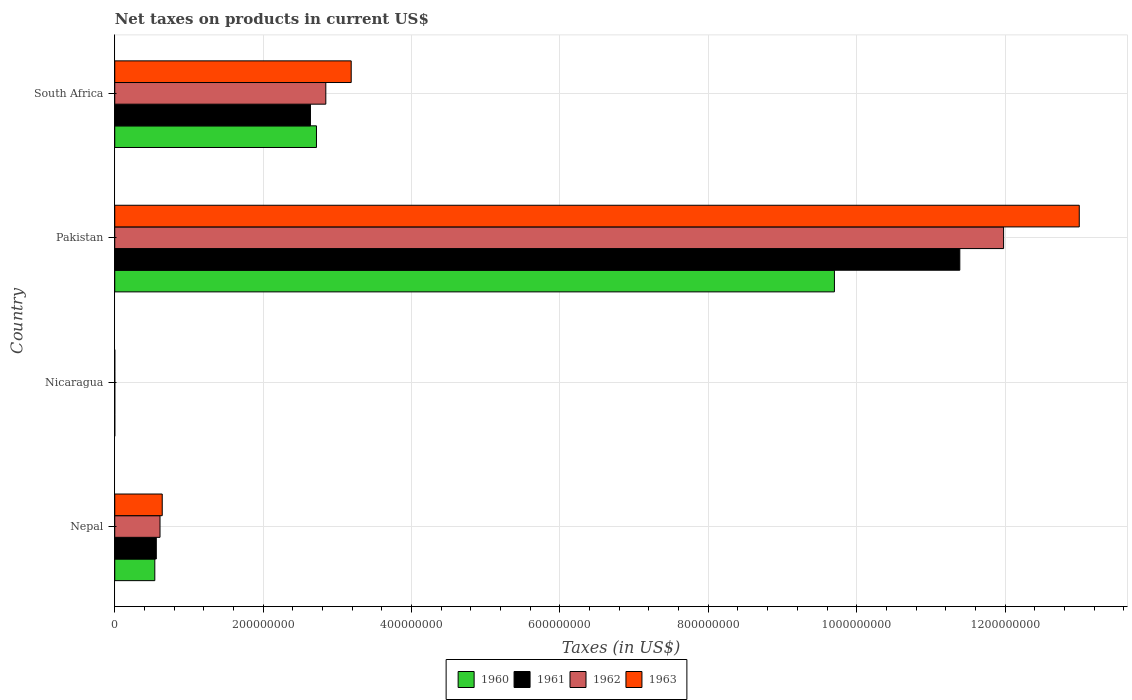Are the number of bars on each tick of the Y-axis equal?
Make the answer very short. Yes. How many bars are there on the 2nd tick from the bottom?
Your response must be concise. 4. What is the label of the 3rd group of bars from the top?
Make the answer very short. Nicaragua. In how many cases, is the number of bars for a given country not equal to the number of legend labels?
Ensure brevity in your answer.  0. What is the net taxes on products in 1962 in Nicaragua?
Your answer should be very brief. 0.04. Across all countries, what is the maximum net taxes on products in 1963?
Ensure brevity in your answer.  1.30e+09. Across all countries, what is the minimum net taxes on products in 1960?
Ensure brevity in your answer.  0.03. In which country was the net taxes on products in 1960 minimum?
Your answer should be compact. Nicaragua. What is the total net taxes on products in 1962 in the graph?
Keep it short and to the point. 1.54e+09. What is the difference between the net taxes on products in 1963 in Nicaragua and that in Pakistan?
Ensure brevity in your answer.  -1.30e+09. What is the difference between the net taxes on products in 1962 in Nepal and the net taxes on products in 1961 in Pakistan?
Provide a short and direct response. -1.08e+09. What is the average net taxes on products in 1962 per country?
Provide a short and direct response. 3.86e+08. What is the difference between the net taxes on products in 1963 and net taxes on products in 1961 in Nicaragua?
Your answer should be compact. 0.01. What is the ratio of the net taxes on products in 1963 in Pakistan to that in South Africa?
Your answer should be very brief. 4.08. Is the net taxes on products in 1962 in Nepal less than that in Nicaragua?
Provide a succinct answer. No. What is the difference between the highest and the second highest net taxes on products in 1960?
Give a very brief answer. 6.98e+08. What is the difference between the highest and the lowest net taxes on products in 1962?
Your answer should be compact. 1.20e+09. In how many countries, is the net taxes on products in 1963 greater than the average net taxes on products in 1963 taken over all countries?
Offer a very short reply. 1. Is the sum of the net taxes on products in 1961 in Nicaragua and Pakistan greater than the maximum net taxes on products in 1960 across all countries?
Keep it short and to the point. Yes. What does the 1st bar from the top in Nepal represents?
Provide a short and direct response. 1963. What does the 2nd bar from the bottom in Pakistan represents?
Ensure brevity in your answer.  1961. Is it the case that in every country, the sum of the net taxes on products in 1960 and net taxes on products in 1961 is greater than the net taxes on products in 1963?
Your answer should be compact. Yes. Are all the bars in the graph horizontal?
Your answer should be very brief. Yes. What is the difference between two consecutive major ticks on the X-axis?
Offer a very short reply. 2.00e+08. Does the graph contain any zero values?
Provide a succinct answer. No. Where does the legend appear in the graph?
Keep it short and to the point. Bottom center. What is the title of the graph?
Your response must be concise. Net taxes on products in current US$. Does "1980" appear as one of the legend labels in the graph?
Your answer should be very brief. No. What is the label or title of the X-axis?
Ensure brevity in your answer.  Taxes (in US$). What is the label or title of the Y-axis?
Ensure brevity in your answer.  Country. What is the Taxes (in US$) of 1960 in Nepal?
Your answer should be very brief. 5.40e+07. What is the Taxes (in US$) in 1961 in Nepal?
Keep it short and to the point. 5.60e+07. What is the Taxes (in US$) of 1962 in Nepal?
Your response must be concise. 6.10e+07. What is the Taxes (in US$) in 1963 in Nepal?
Make the answer very short. 6.40e+07. What is the Taxes (in US$) in 1960 in Nicaragua?
Your answer should be compact. 0.03. What is the Taxes (in US$) of 1961 in Nicaragua?
Make the answer very short. 0.03. What is the Taxes (in US$) in 1962 in Nicaragua?
Your answer should be compact. 0.04. What is the Taxes (in US$) of 1963 in Nicaragua?
Offer a terse response. 0.04. What is the Taxes (in US$) of 1960 in Pakistan?
Make the answer very short. 9.70e+08. What is the Taxes (in US$) in 1961 in Pakistan?
Keep it short and to the point. 1.14e+09. What is the Taxes (in US$) in 1962 in Pakistan?
Give a very brief answer. 1.20e+09. What is the Taxes (in US$) of 1963 in Pakistan?
Give a very brief answer. 1.30e+09. What is the Taxes (in US$) in 1960 in South Africa?
Offer a terse response. 2.72e+08. What is the Taxes (in US$) of 1961 in South Africa?
Keep it short and to the point. 2.64e+08. What is the Taxes (in US$) of 1962 in South Africa?
Provide a succinct answer. 2.84e+08. What is the Taxes (in US$) of 1963 in South Africa?
Keep it short and to the point. 3.19e+08. Across all countries, what is the maximum Taxes (in US$) of 1960?
Make the answer very short. 9.70e+08. Across all countries, what is the maximum Taxes (in US$) of 1961?
Give a very brief answer. 1.14e+09. Across all countries, what is the maximum Taxes (in US$) in 1962?
Your response must be concise. 1.20e+09. Across all countries, what is the maximum Taxes (in US$) of 1963?
Ensure brevity in your answer.  1.30e+09. Across all countries, what is the minimum Taxes (in US$) in 1960?
Provide a succinct answer. 0.03. Across all countries, what is the minimum Taxes (in US$) in 1961?
Offer a terse response. 0.03. Across all countries, what is the minimum Taxes (in US$) of 1962?
Your answer should be compact. 0.04. Across all countries, what is the minimum Taxes (in US$) in 1963?
Your answer should be compact. 0.04. What is the total Taxes (in US$) of 1960 in the graph?
Provide a short and direct response. 1.30e+09. What is the total Taxes (in US$) in 1961 in the graph?
Your response must be concise. 1.46e+09. What is the total Taxes (in US$) of 1962 in the graph?
Ensure brevity in your answer.  1.54e+09. What is the total Taxes (in US$) of 1963 in the graph?
Give a very brief answer. 1.68e+09. What is the difference between the Taxes (in US$) of 1960 in Nepal and that in Nicaragua?
Provide a short and direct response. 5.40e+07. What is the difference between the Taxes (in US$) of 1961 in Nepal and that in Nicaragua?
Your response must be concise. 5.60e+07. What is the difference between the Taxes (in US$) of 1962 in Nepal and that in Nicaragua?
Provide a succinct answer. 6.10e+07. What is the difference between the Taxes (in US$) of 1963 in Nepal and that in Nicaragua?
Give a very brief answer. 6.40e+07. What is the difference between the Taxes (in US$) in 1960 in Nepal and that in Pakistan?
Ensure brevity in your answer.  -9.16e+08. What is the difference between the Taxes (in US$) of 1961 in Nepal and that in Pakistan?
Give a very brief answer. -1.08e+09. What is the difference between the Taxes (in US$) in 1962 in Nepal and that in Pakistan?
Your answer should be compact. -1.14e+09. What is the difference between the Taxes (in US$) in 1963 in Nepal and that in Pakistan?
Your response must be concise. -1.24e+09. What is the difference between the Taxes (in US$) of 1960 in Nepal and that in South Africa?
Provide a short and direct response. -2.18e+08. What is the difference between the Taxes (in US$) of 1961 in Nepal and that in South Africa?
Provide a short and direct response. -2.08e+08. What is the difference between the Taxes (in US$) in 1962 in Nepal and that in South Africa?
Give a very brief answer. -2.23e+08. What is the difference between the Taxes (in US$) in 1963 in Nepal and that in South Africa?
Your response must be concise. -2.55e+08. What is the difference between the Taxes (in US$) of 1960 in Nicaragua and that in Pakistan?
Your response must be concise. -9.70e+08. What is the difference between the Taxes (in US$) of 1961 in Nicaragua and that in Pakistan?
Offer a very short reply. -1.14e+09. What is the difference between the Taxes (in US$) in 1962 in Nicaragua and that in Pakistan?
Your response must be concise. -1.20e+09. What is the difference between the Taxes (in US$) in 1963 in Nicaragua and that in Pakistan?
Provide a short and direct response. -1.30e+09. What is the difference between the Taxes (in US$) of 1960 in Nicaragua and that in South Africa?
Your answer should be very brief. -2.72e+08. What is the difference between the Taxes (in US$) in 1961 in Nicaragua and that in South Africa?
Offer a terse response. -2.64e+08. What is the difference between the Taxes (in US$) in 1962 in Nicaragua and that in South Africa?
Keep it short and to the point. -2.84e+08. What is the difference between the Taxes (in US$) in 1963 in Nicaragua and that in South Africa?
Your answer should be very brief. -3.19e+08. What is the difference between the Taxes (in US$) of 1960 in Pakistan and that in South Africa?
Your answer should be very brief. 6.98e+08. What is the difference between the Taxes (in US$) of 1961 in Pakistan and that in South Africa?
Your answer should be very brief. 8.75e+08. What is the difference between the Taxes (in US$) in 1962 in Pakistan and that in South Africa?
Ensure brevity in your answer.  9.14e+08. What is the difference between the Taxes (in US$) in 1963 in Pakistan and that in South Africa?
Your response must be concise. 9.81e+08. What is the difference between the Taxes (in US$) of 1960 in Nepal and the Taxes (in US$) of 1961 in Nicaragua?
Provide a short and direct response. 5.40e+07. What is the difference between the Taxes (in US$) in 1960 in Nepal and the Taxes (in US$) in 1962 in Nicaragua?
Your answer should be compact. 5.40e+07. What is the difference between the Taxes (in US$) of 1960 in Nepal and the Taxes (in US$) of 1963 in Nicaragua?
Give a very brief answer. 5.40e+07. What is the difference between the Taxes (in US$) of 1961 in Nepal and the Taxes (in US$) of 1962 in Nicaragua?
Provide a succinct answer. 5.60e+07. What is the difference between the Taxes (in US$) in 1961 in Nepal and the Taxes (in US$) in 1963 in Nicaragua?
Provide a succinct answer. 5.60e+07. What is the difference between the Taxes (in US$) in 1962 in Nepal and the Taxes (in US$) in 1963 in Nicaragua?
Give a very brief answer. 6.10e+07. What is the difference between the Taxes (in US$) of 1960 in Nepal and the Taxes (in US$) of 1961 in Pakistan?
Your answer should be very brief. -1.08e+09. What is the difference between the Taxes (in US$) of 1960 in Nepal and the Taxes (in US$) of 1962 in Pakistan?
Keep it short and to the point. -1.14e+09. What is the difference between the Taxes (in US$) in 1960 in Nepal and the Taxes (in US$) in 1963 in Pakistan?
Ensure brevity in your answer.  -1.25e+09. What is the difference between the Taxes (in US$) in 1961 in Nepal and the Taxes (in US$) in 1962 in Pakistan?
Give a very brief answer. -1.14e+09. What is the difference between the Taxes (in US$) in 1961 in Nepal and the Taxes (in US$) in 1963 in Pakistan?
Provide a short and direct response. -1.24e+09. What is the difference between the Taxes (in US$) in 1962 in Nepal and the Taxes (in US$) in 1963 in Pakistan?
Provide a succinct answer. -1.24e+09. What is the difference between the Taxes (in US$) in 1960 in Nepal and the Taxes (in US$) in 1961 in South Africa?
Your answer should be very brief. -2.10e+08. What is the difference between the Taxes (in US$) in 1960 in Nepal and the Taxes (in US$) in 1962 in South Africa?
Offer a very short reply. -2.30e+08. What is the difference between the Taxes (in US$) of 1960 in Nepal and the Taxes (in US$) of 1963 in South Africa?
Keep it short and to the point. -2.65e+08. What is the difference between the Taxes (in US$) of 1961 in Nepal and the Taxes (in US$) of 1962 in South Africa?
Provide a succinct answer. -2.28e+08. What is the difference between the Taxes (in US$) in 1961 in Nepal and the Taxes (in US$) in 1963 in South Africa?
Your answer should be very brief. -2.63e+08. What is the difference between the Taxes (in US$) of 1962 in Nepal and the Taxes (in US$) of 1963 in South Africa?
Offer a terse response. -2.58e+08. What is the difference between the Taxes (in US$) of 1960 in Nicaragua and the Taxes (in US$) of 1961 in Pakistan?
Keep it short and to the point. -1.14e+09. What is the difference between the Taxes (in US$) of 1960 in Nicaragua and the Taxes (in US$) of 1962 in Pakistan?
Keep it short and to the point. -1.20e+09. What is the difference between the Taxes (in US$) in 1960 in Nicaragua and the Taxes (in US$) in 1963 in Pakistan?
Give a very brief answer. -1.30e+09. What is the difference between the Taxes (in US$) of 1961 in Nicaragua and the Taxes (in US$) of 1962 in Pakistan?
Your answer should be compact. -1.20e+09. What is the difference between the Taxes (in US$) in 1961 in Nicaragua and the Taxes (in US$) in 1963 in Pakistan?
Your answer should be very brief. -1.30e+09. What is the difference between the Taxes (in US$) in 1962 in Nicaragua and the Taxes (in US$) in 1963 in Pakistan?
Make the answer very short. -1.30e+09. What is the difference between the Taxes (in US$) of 1960 in Nicaragua and the Taxes (in US$) of 1961 in South Africa?
Your answer should be very brief. -2.64e+08. What is the difference between the Taxes (in US$) in 1960 in Nicaragua and the Taxes (in US$) in 1962 in South Africa?
Your answer should be very brief. -2.84e+08. What is the difference between the Taxes (in US$) in 1960 in Nicaragua and the Taxes (in US$) in 1963 in South Africa?
Provide a short and direct response. -3.19e+08. What is the difference between the Taxes (in US$) in 1961 in Nicaragua and the Taxes (in US$) in 1962 in South Africa?
Ensure brevity in your answer.  -2.84e+08. What is the difference between the Taxes (in US$) in 1961 in Nicaragua and the Taxes (in US$) in 1963 in South Africa?
Offer a very short reply. -3.19e+08. What is the difference between the Taxes (in US$) of 1962 in Nicaragua and the Taxes (in US$) of 1963 in South Africa?
Your answer should be compact. -3.19e+08. What is the difference between the Taxes (in US$) of 1960 in Pakistan and the Taxes (in US$) of 1961 in South Africa?
Make the answer very short. 7.06e+08. What is the difference between the Taxes (in US$) of 1960 in Pakistan and the Taxes (in US$) of 1962 in South Africa?
Make the answer very short. 6.86e+08. What is the difference between the Taxes (in US$) of 1960 in Pakistan and the Taxes (in US$) of 1963 in South Africa?
Offer a very short reply. 6.51e+08. What is the difference between the Taxes (in US$) in 1961 in Pakistan and the Taxes (in US$) in 1962 in South Africa?
Provide a succinct answer. 8.55e+08. What is the difference between the Taxes (in US$) of 1961 in Pakistan and the Taxes (in US$) of 1963 in South Africa?
Your answer should be compact. 8.20e+08. What is the difference between the Taxes (in US$) in 1962 in Pakistan and the Taxes (in US$) in 1963 in South Africa?
Make the answer very short. 8.79e+08. What is the average Taxes (in US$) in 1960 per country?
Your answer should be compact. 3.24e+08. What is the average Taxes (in US$) of 1961 per country?
Your response must be concise. 3.65e+08. What is the average Taxes (in US$) in 1962 per country?
Make the answer very short. 3.86e+08. What is the average Taxes (in US$) in 1963 per country?
Your answer should be compact. 4.21e+08. What is the difference between the Taxes (in US$) of 1960 and Taxes (in US$) of 1961 in Nepal?
Keep it short and to the point. -2.00e+06. What is the difference between the Taxes (in US$) of 1960 and Taxes (in US$) of 1962 in Nepal?
Give a very brief answer. -7.00e+06. What is the difference between the Taxes (in US$) in 1960 and Taxes (in US$) in 1963 in Nepal?
Your response must be concise. -1.00e+07. What is the difference between the Taxes (in US$) of 1961 and Taxes (in US$) of 1962 in Nepal?
Offer a terse response. -5.00e+06. What is the difference between the Taxes (in US$) of 1961 and Taxes (in US$) of 1963 in Nepal?
Provide a short and direct response. -8.00e+06. What is the difference between the Taxes (in US$) in 1962 and Taxes (in US$) in 1963 in Nepal?
Your answer should be very brief. -3.00e+06. What is the difference between the Taxes (in US$) of 1960 and Taxes (in US$) of 1961 in Nicaragua?
Provide a short and direct response. -0. What is the difference between the Taxes (in US$) of 1960 and Taxes (in US$) of 1962 in Nicaragua?
Keep it short and to the point. -0.01. What is the difference between the Taxes (in US$) of 1960 and Taxes (in US$) of 1963 in Nicaragua?
Your answer should be compact. -0.01. What is the difference between the Taxes (in US$) in 1961 and Taxes (in US$) in 1962 in Nicaragua?
Make the answer very short. -0. What is the difference between the Taxes (in US$) of 1961 and Taxes (in US$) of 1963 in Nicaragua?
Offer a terse response. -0.01. What is the difference between the Taxes (in US$) in 1962 and Taxes (in US$) in 1963 in Nicaragua?
Make the answer very short. -0.01. What is the difference between the Taxes (in US$) in 1960 and Taxes (in US$) in 1961 in Pakistan?
Offer a terse response. -1.69e+08. What is the difference between the Taxes (in US$) in 1960 and Taxes (in US$) in 1962 in Pakistan?
Your response must be concise. -2.28e+08. What is the difference between the Taxes (in US$) of 1960 and Taxes (in US$) of 1963 in Pakistan?
Your answer should be very brief. -3.30e+08. What is the difference between the Taxes (in US$) in 1961 and Taxes (in US$) in 1962 in Pakistan?
Offer a terse response. -5.90e+07. What is the difference between the Taxes (in US$) in 1961 and Taxes (in US$) in 1963 in Pakistan?
Give a very brief answer. -1.61e+08. What is the difference between the Taxes (in US$) of 1962 and Taxes (in US$) of 1963 in Pakistan?
Give a very brief answer. -1.02e+08. What is the difference between the Taxes (in US$) of 1960 and Taxes (in US$) of 1961 in South Africa?
Your answer should be compact. 8.10e+06. What is the difference between the Taxes (in US$) of 1960 and Taxes (in US$) of 1962 in South Africa?
Offer a terse response. -1.26e+07. What is the difference between the Taxes (in US$) of 1960 and Taxes (in US$) of 1963 in South Africa?
Provide a succinct answer. -4.68e+07. What is the difference between the Taxes (in US$) of 1961 and Taxes (in US$) of 1962 in South Africa?
Provide a short and direct response. -2.07e+07. What is the difference between the Taxes (in US$) in 1961 and Taxes (in US$) in 1963 in South Africa?
Ensure brevity in your answer.  -5.49e+07. What is the difference between the Taxes (in US$) in 1962 and Taxes (in US$) in 1963 in South Africa?
Your answer should be very brief. -3.42e+07. What is the ratio of the Taxes (in US$) of 1960 in Nepal to that in Nicaragua?
Offer a terse response. 1.81e+09. What is the ratio of the Taxes (in US$) of 1961 in Nepal to that in Nicaragua?
Keep it short and to the point. 1.80e+09. What is the ratio of the Taxes (in US$) of 1962 in Nepal to that in Nicaragua?
Offer a very short reply. 1.73e+09. What is the ratio of the Taxes (in US$) of 1963 in Nepal to that in Nicaragua?
Offer a very short reply. 1.54e+09. What is the ratio of the Taxes (in US$) in 1960 in Nepal to that in Pakistan?
Provide a succinct answer. 0.06. What is the ratio of the Taxes (in US$) of 1961 in Nepal to that in Pakistan?
Provide a short and direct response. 0.05. What is the ratio of the Taxes (in US$) of 1962 in Nepal to that in Pakistan?
Your answer should be compact. 0.05. What is the ratio of the Taxes (in US$) in 1963 in Nepal to that in Pakistan?
Provide a short and direct response. 0.05. What is the ratio of the Taxes (in US$) in 1960 in Nepal to that in South Africa?
Provide a succinct answer. 0.2. What is the ratio of the Taxes (in US$) of 1961 in Nepal to that in South Africa?
Your response must be concise. 0.21. What is the ratio of the Taxes (in US$) in 1962 in Nepal to that in South Africa?
Your response must be concise. 0.21. What is the ratio of the Taxes (in US$) in 1963 in Nepal to that in South Africa?
Provide a short and direct response. 0.2. What is the ratio of the Taxes (in US$) of 1961 in Nicaragua to that in Pakistan?
Your answer should be very brief. 0. What is the ratio of the Taxes (in US$) of 1960 in Nicaragua to that in South Africa?
Provide a short and direct response. 0. What is the ratio of the Taxes (in US$) of 1963 in Nicaragua to that in South Africa?
Your answer should be compact. 0. What is the ratio of the Taxes (in US$) in 1960 in Pakistan to that in South Africa?
Offer a terse response. 3.57. What is the ratio of the Taxes (in US$) of 1961 in Pakistan to that in South Africa?
Offer a terse response. 4.32. What is the ratio of the Taxes (in US$) of 1962 in Pakistan to that in South Africa?
Provide a short and direct response. 4.21. What is the ratio of the Taxes (in US$) in 1963 in Pakistan to that in South Africa?
Ensure brevity in your answer.  4.08. What is the difference between the highest and the second highest Taxes (in US$) of 1960?
Give a very brief answer. 6.98e+08. What is the difference between the highest and the second highest Taxes (in US$) of 1961?
Give a very brief answer. 8.75e+08. What is the difference between the highest and the second highest Taxes (in US$) of 1962?
Provide a succinct answer. 9.14e+08. What is the difference between the highest and the second highest Taxes (in US$) of 1963?
Provide a short and direct response. 9.81e+08. What is the difference between the highest and the lowest Taxes (in US$) in 1960?
Offer a very short reply. 9.70e+08. What is the difference between the highest and the lowest Taxes (in US$) of 1961?
Keep it short and to the point. 1.14e+09. What is the difference between the highest and the lowest Taxes (in US$) in 1962?
Ensure brevity in your answer.  1.20e+09. What is the difference between the highest and the lowest Taxes (in US$) of 1963?
Your response must be concise. 1.30e+09. 